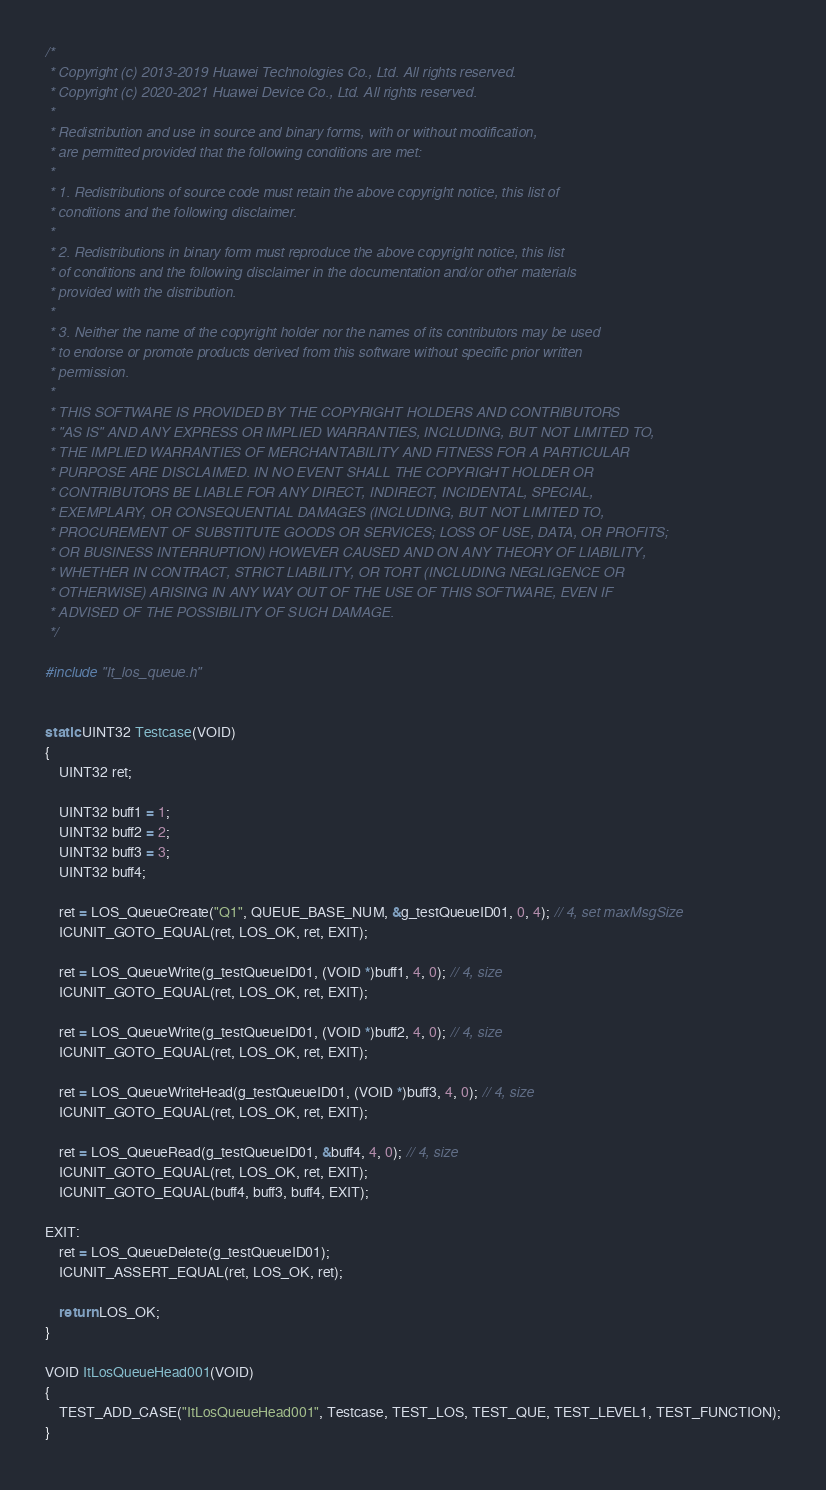<code> <loc_0><loc_0><loc_500><loc_500><_C_>/*
 * Copyright (c) 2013-2019 Huawei Technologies Co., Ltd. All rights reserved.
 * Copyright (c) 2020-2021 Huawei Device Co., Ltd. All rights reserved.
 *
 * Redistribution and use in source and binary forms, with or without modification,
 * are permitted provided that the following conditions are met:
 *
 * 1. Redistributions of source code must retain the above copyright notice, this list of
 * conditions and the following disclaimer.
 *
 * 2. Redistributions in binary form must reproduce the above copyright notice, this list
 * of conditions and the following disclaimer in the documentation and/or other materials
 * provided with the distribution.
 *
 * 3. Neither the name of the copyright holder nor the names of its contributors may be used
 * to endorse or promote products derived from this software without specific prior written
 * permission.
 *
 * THIS SOFTWARE IS PROVIDED BY THE COPYRIGHT HOLDERS AND CONTRIBUTORS
 * "AS IS" AND ANY EXPRESS OR IMPLIED WARRANTIES, INCLUDING, BUT NOT LIMITED TO,
 * THE IMPLIED WARRANTIES OF MERCHANTABILITY AND FITNESS FOR A PARTICULAR
 * PURPOSE ARE DISCLAIMED. IN NO EVENT SHALL THE COPYRIGHT HOLDER OR
 * CONTRIBUTORS BE LIABLE FOR ANY DIRECT, INDIRECT, INCIDENTAL, SPECIAL,
 * EXEMPLARY, OR CONSEQUENTIAL DAMAGES (INCLUDING, BUT NOT LIMITED TO,
 * PROCUREMENT OF SUBSTITUTE GOODS OR SERVICES; LOSS OF USE, DATA, OR PROFITS;
 * OR BUSINESS INTERRUPTION) HOWEVER CAUSED AND ON ANY THEORY OF LIABILITY,
 * WHETHER IN CONTRACT, STRICT LIABILITY, OR TORT (INCLUDING NEGLIGENCE OR
 * OTHERWISE) ARISING IN ANY WAY OUT OF THE USE OF THIS SOFTWARE, EVEN IF
 * ADVISED OF THE POSSIBILITY OF SUCH DAMAGE.
 */

#include "It_los_queue.h"


static UINT32 Testcase(VOID)
{
    UINT32 ret;

    UINT32 buff1 = 1;
    UINT32 buff2 = 2;
    UINT32 buff3 = 3;
    UINT32 buff4;

    ret = LOS_QueueCreate("Q1", QUEUE_BASE_NUM, &g_testQueueID01, 0, 4); // 4, set maxMsgSize
    ICUNIT_GOTO_EQUAL(ret, LOS_OK, ret, EXIT);

    ret = LOS_QueueWrite(g_testQueueID01, (VOID *)buff1, 4, 0); // 4, size
    ICUNIT_GOTO_EQUAL(ret, LOS_OK, ret, EXIT);

    ret = LOS_QueueWrite(g_testQueueID01, (VOID *)buff2, 4, 0); // 4, size
    ICUNIT_GOTO_EQUAL(ret, LOS_OK, ret, EXIT);

    ret = LOS_QueueWriteHead(g_testQueueID01, (VOID *)buff3, 4, 0); // 4, size
    ICUNIT_GOTO_EQUAL(ret, LOS_OK, ret, EXIT);

    ret = LOS_QueueRead(g_testQueueID01, &buff4, 4, 0); // 4, size
    ICUNIT_GOTO_EQUAL(ret, LOS_OK, ret, EXIT);
    ICUNIT_GOTO_EQUAL(buff4, buff3, buff4, EXIT);

EXIT:
    ret = LOS_QueueDelete(g_testQueueID01);
    ICUNIT_ASSERT_EQUAL(ret, LOS_OK, ret);

    return LOS_OK;
}

VOID ItLosQueueHead001(VOID)
{
    TEST_ADD_CASE("ItLosQueueHead001", Testcase, TEST_LOS, TEST_QUE, TEST_LEVEL1, TEST_FUNCTION);
}

</code> 